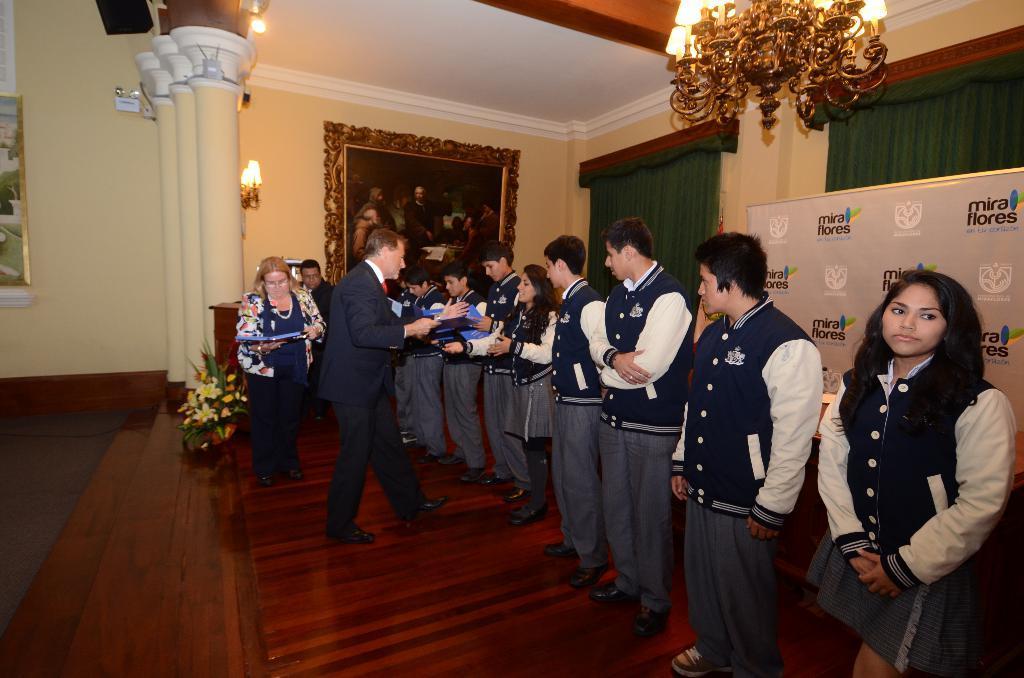Could you give a brief overview of what you see in this image? In this image we can see people standing. The lady standing in the center is holding an object. On the right there is a board. In the background there is a wall and we can see frames placed on the wall. We can see lights. At the top there is a chandelier and there are curtains. At the bottom there is a flower vase placed on the floor. 